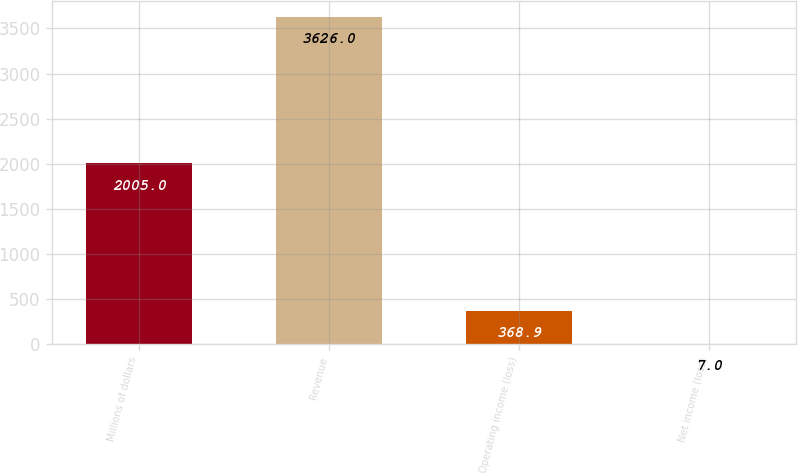<chart> <loc_0><loc_0><loc_500><loc_500><bar_chart><fcel>Millions of dollars<fcel>Revenue<fcel>Operating income (loss)<fcel>Net income (loss)<nl><fcel>2005<fcel>3626<fcel>368.9<fcel>7<nl></chart> 